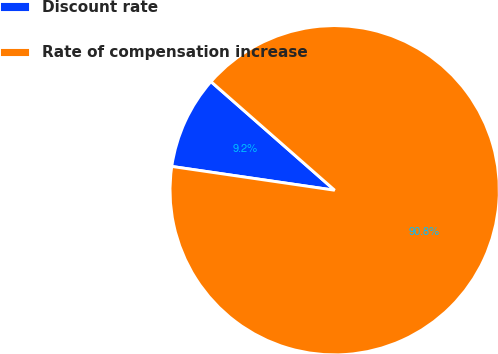Convert chart to OTSL. <chart><loc_0><loc_0><loc_500><loc_500><pie_chart><fcel>Discount rate<fcel>Rate of compensation increase<nl><fcel>9.16%<fcel>90.84%<nl></chart> 